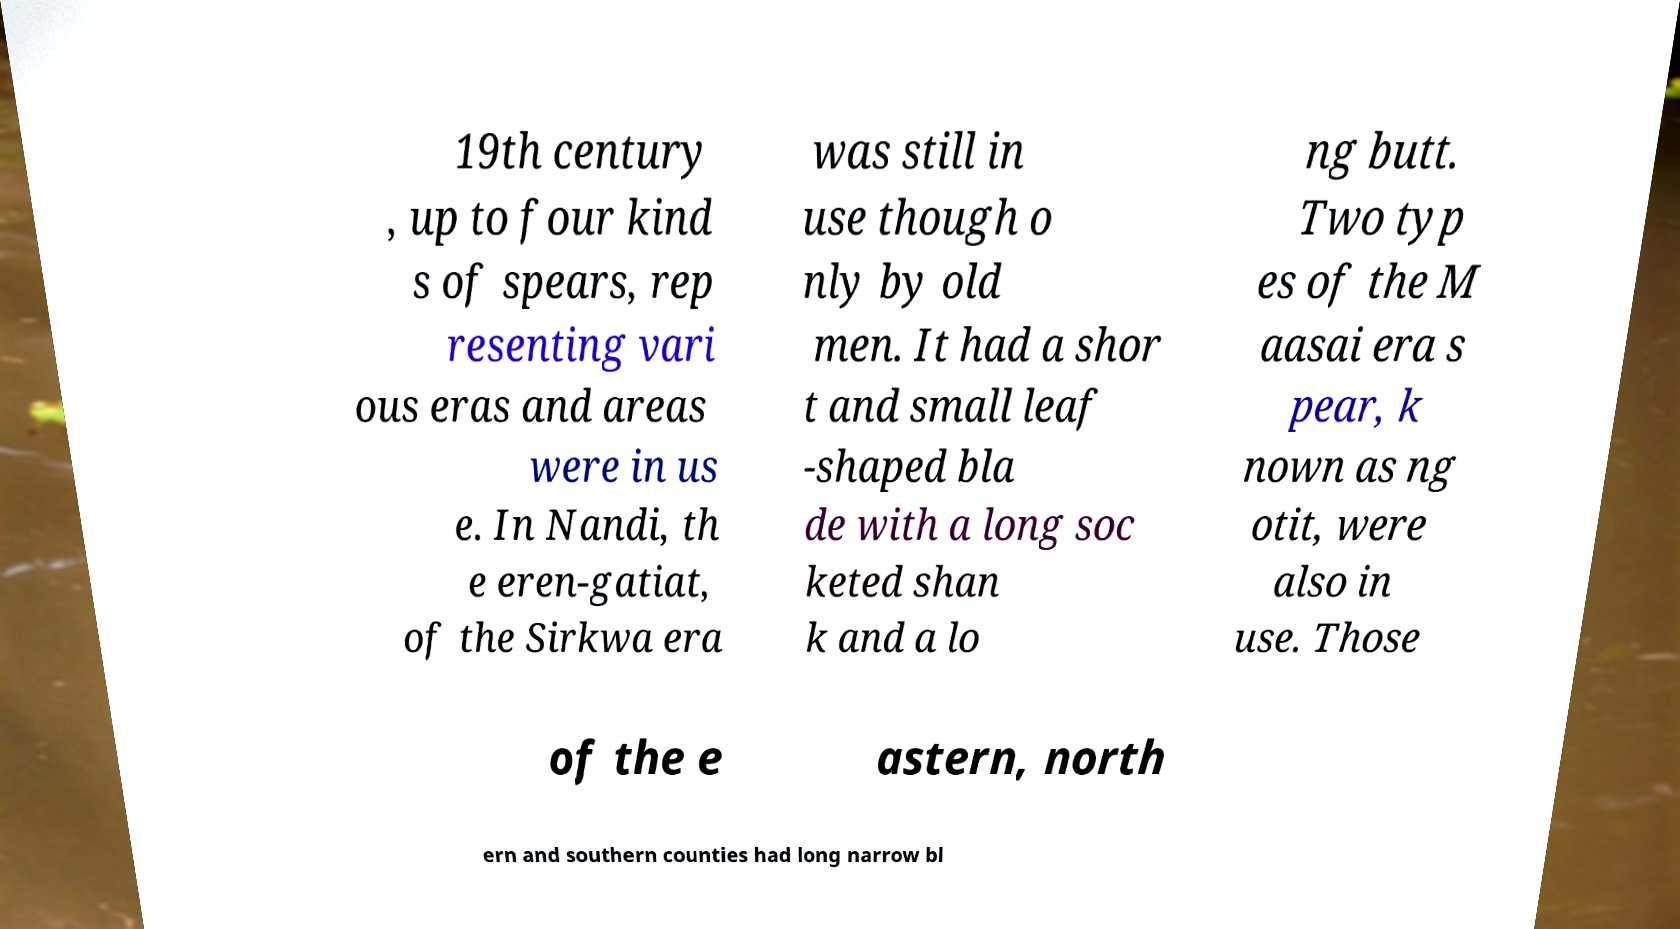I need the written content from this picture converted into text. Can you do that? 19th century , up to four kind s of spears, rep resenting vari ous eras and areas were in us e. In Nandi, th e eren-gatiat, of the Sirkwa era was still in use though o nly by old men. It had a shor t and small leaf -shaped bla de with a long soc keted shan k and a lo ng butt. Two typ es of the M aasai era s pear, k nown as ng otit, were also in use. Those of the e astern, north ern and southern counties had long narrow bl 